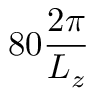<formula> <loc_0><loc_0><loc_500><loc_500>8 0 \frac { 2 \pi } { L _ { z } }</formula> 